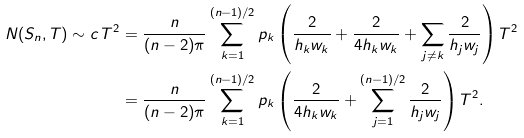Convert formula to latex. <formula><loc_0><loc_0><loc_500><loc_500>N ( S _ { n } , T ) \sim c \, T ^ { 2 } & = \frac { n } { ( n - 2 ) \pi } \sum _ { k = 1 } ^ { ( n - 1 ) / 2 } p _ { k } \left ( \frac { 2 } { h _ { k } w _ { k } } + \frac { 2 } { 4 h _ { k } w _ { k } } + \sum _ { j \ne k } \frac { 2 } { h _ { j } w _ { j } } \right ) T ^ { 2 } \\ & = \frac { n } { ( n - 2 ) \pi } \sum _ { k = 1 } ^ { ( n - 1 ) / 2 } p _ { k } \left ( \frac { 2 } { 4 h _ { k } w _ { k } } + \sum _ { j = 1 } ^ { ( n - 1 ) / 2 } \frac { 2 } { h _ { j } w _ { j } } \right ) T ^ { 2 } . \\</formula> 